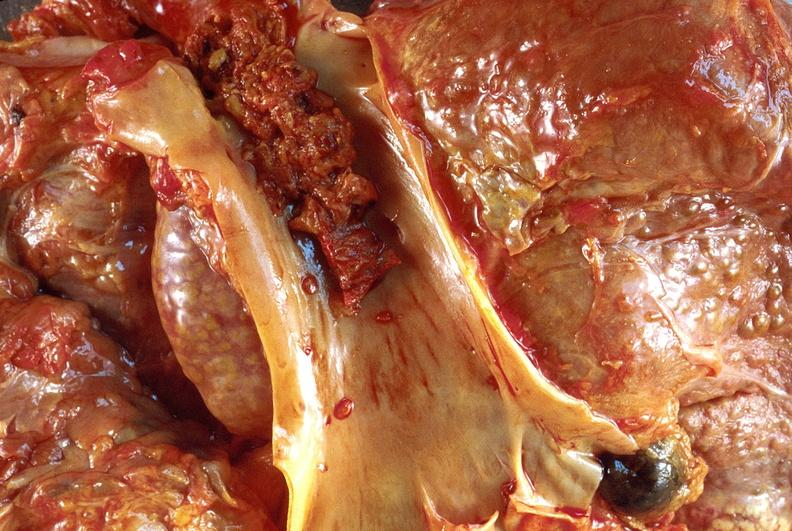s hepatobiliary present?
Answer the question using a single word or phrase. Yes 